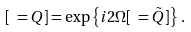<formula> <loc_0><loc_0><loc_500><loc_500>[ \ = Q ] = \exp \left \{ i 2 \Omega [ \ = \tilde { Q } ] \right \} \, .</formula> 